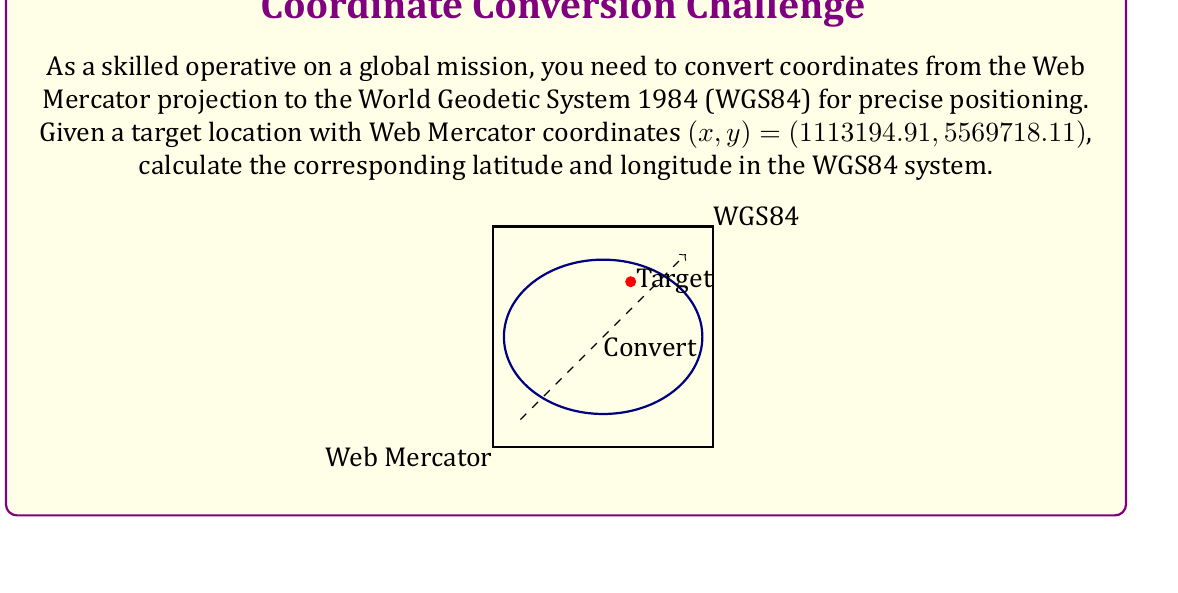Show me your answer to this math problem. To convert from Web Mercator to WGS84, we'll follow these steps:

1) First, normalize the Web Mercator coordinates:

   $$x_n = \frac{x}{R} - \pi$$
   $$y_n = \frac{y}{R} - \pi$$

   Where R is the Earth's radius (6378137 meters).

   $$x_n = \frac{1113194.91}{6378137} - \pi \approx -2.8935$$
   $$y_n = \frac{5569718.11}{6378137} - \pi \approx -0.7290$$

2) Calculate the longitude (λ):

   $$\lambda = x_n$$

   So, λ ≈ -2.8935 radians

3) Calculate the latitude (φ):

   $$\phi = 2 \cdot \arctan(e^{y_n}) - \frac{\pi}{2}$$

   $$\phi = 2 \cdot \arctan(e^{-0.7290}) - \frac{\pi}{2} \approx 0.7854$$

4) Convert radians to degrees:

   $$\lambda_{degrees} = \lambda \cdot \frac{180}{\pi} \approx -165.7742°$$
   $$\phi_{degrees} = \phi \cdot \frac{180}{\pi} \approx 45.0000°$$

5) Round to 4 decimal places for standard GPS precision.
Answer: (45.0000°, -165.7742°) 